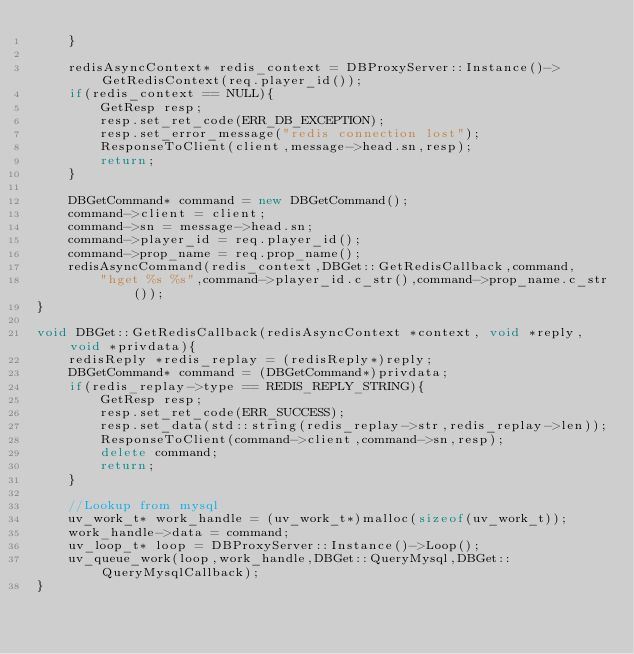<code> <loc_0><loc_0><loc_500><loc_500><_C++_>    }

    redisAsyncContext* redis_context = DBProxyServer::Instance()->GetRedisContext(req.player_id());
    if(redis_context == NULL){
        GetResp resp;
        resp.set_ret_code(ERR_DB_EXCEPTION);
        resp.set_error_message("redis connection lost");
        ResponseToClient(client,message->head.sn,resp);
        return;
    }
    
    DBGetCommand* command = new DBGetCommand();
    command->client = client;
    command->sn = message->head.sn;
    command->player_id = req.player_id();
    command->prop_name = req.prop_name();
    redisAsyncCommand(redis_context,DBGet::GetRedisCallback,command,
        "hget %s %s",command->player_id.c_str(),command->prop_name.c_str());
}

void DBGet::GetRedisCallback(redisAsyncContext *context, void *reply, void *privdata){
    redisReply *redis_replay = (redisReply*)reply;
    DBGetCommand* command = (DBGetCommand*)privdata;    
    if(redis_replay->type == REDIS_REPLY_STRING){        
        GetResp resp;
        resp.set_ret_code(ERR_SUCCESS);
        resp.set_data(std::string(redis_replay->str,redis_replay->len));
        ResponseToClient(command->client,command->sn,resp);
        delete command;
        return;
    }

    //Lookup from mysql
    uv_work_t* work_handle = (uv_work_t*)malloc(sizeof(uv_work_t));
    work_handle->data = command;
    uv_loop_t* loop = DBProxyServer::Instance()->Loop();
    uv_queue_work(loop,work_handle,DBGet::QueryMysql,DBGet::QueryMysqlCallback);
}
</code> 